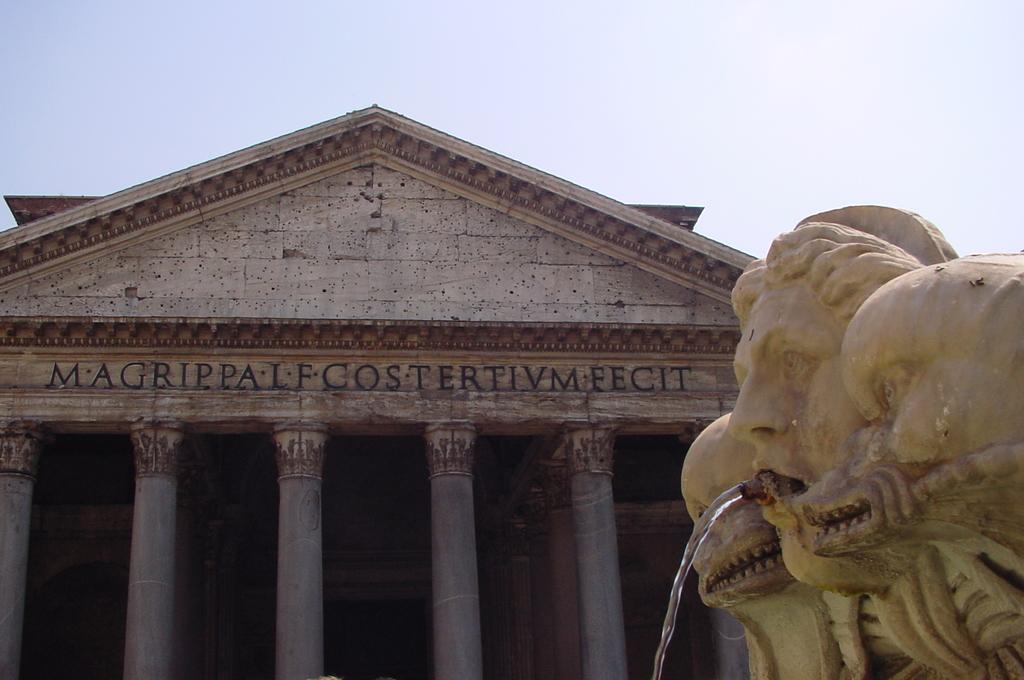Could you give a brief overview of what you see in this image? On the right side of the image there is water flowing from the mouth of the statue, behind the statue there is a building with a name and pillars. 